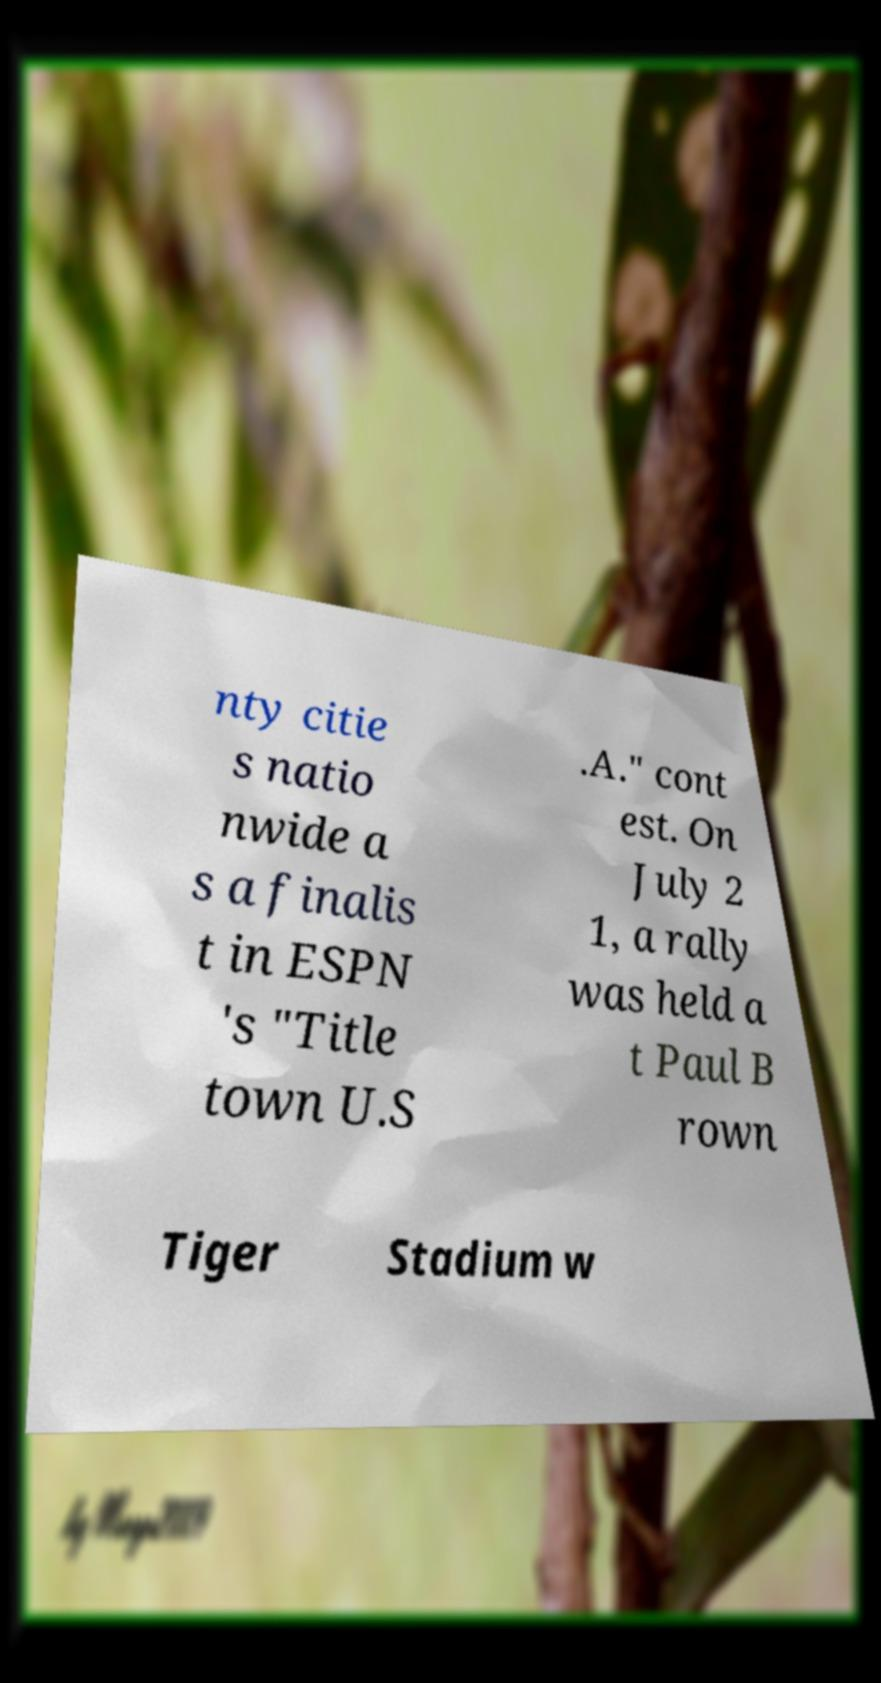I need the written content from this picture converted into text. Can you do that? nty citie s natio nwide a s a finalis t in ESPN 's "Title town U.S .A." cont est. On July 2 1, a rally was held a t Paul B rown Tiger Stadium w 